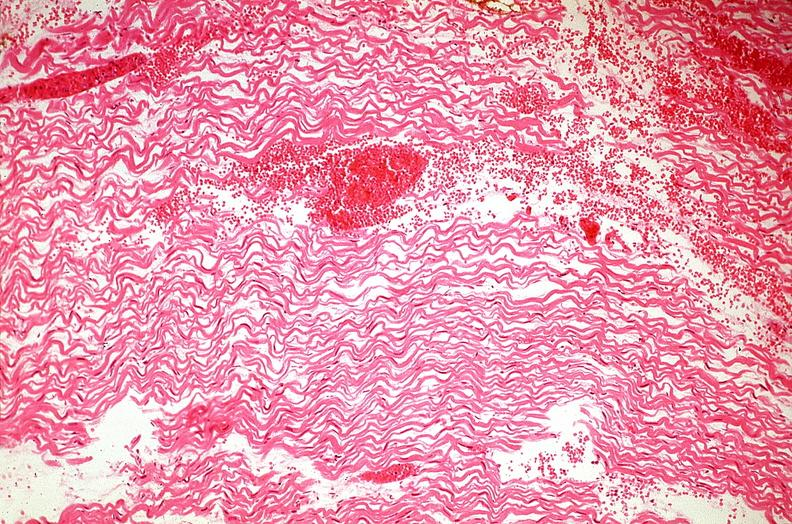where is this from?
Answer the question using a single word or phrase. Heart 